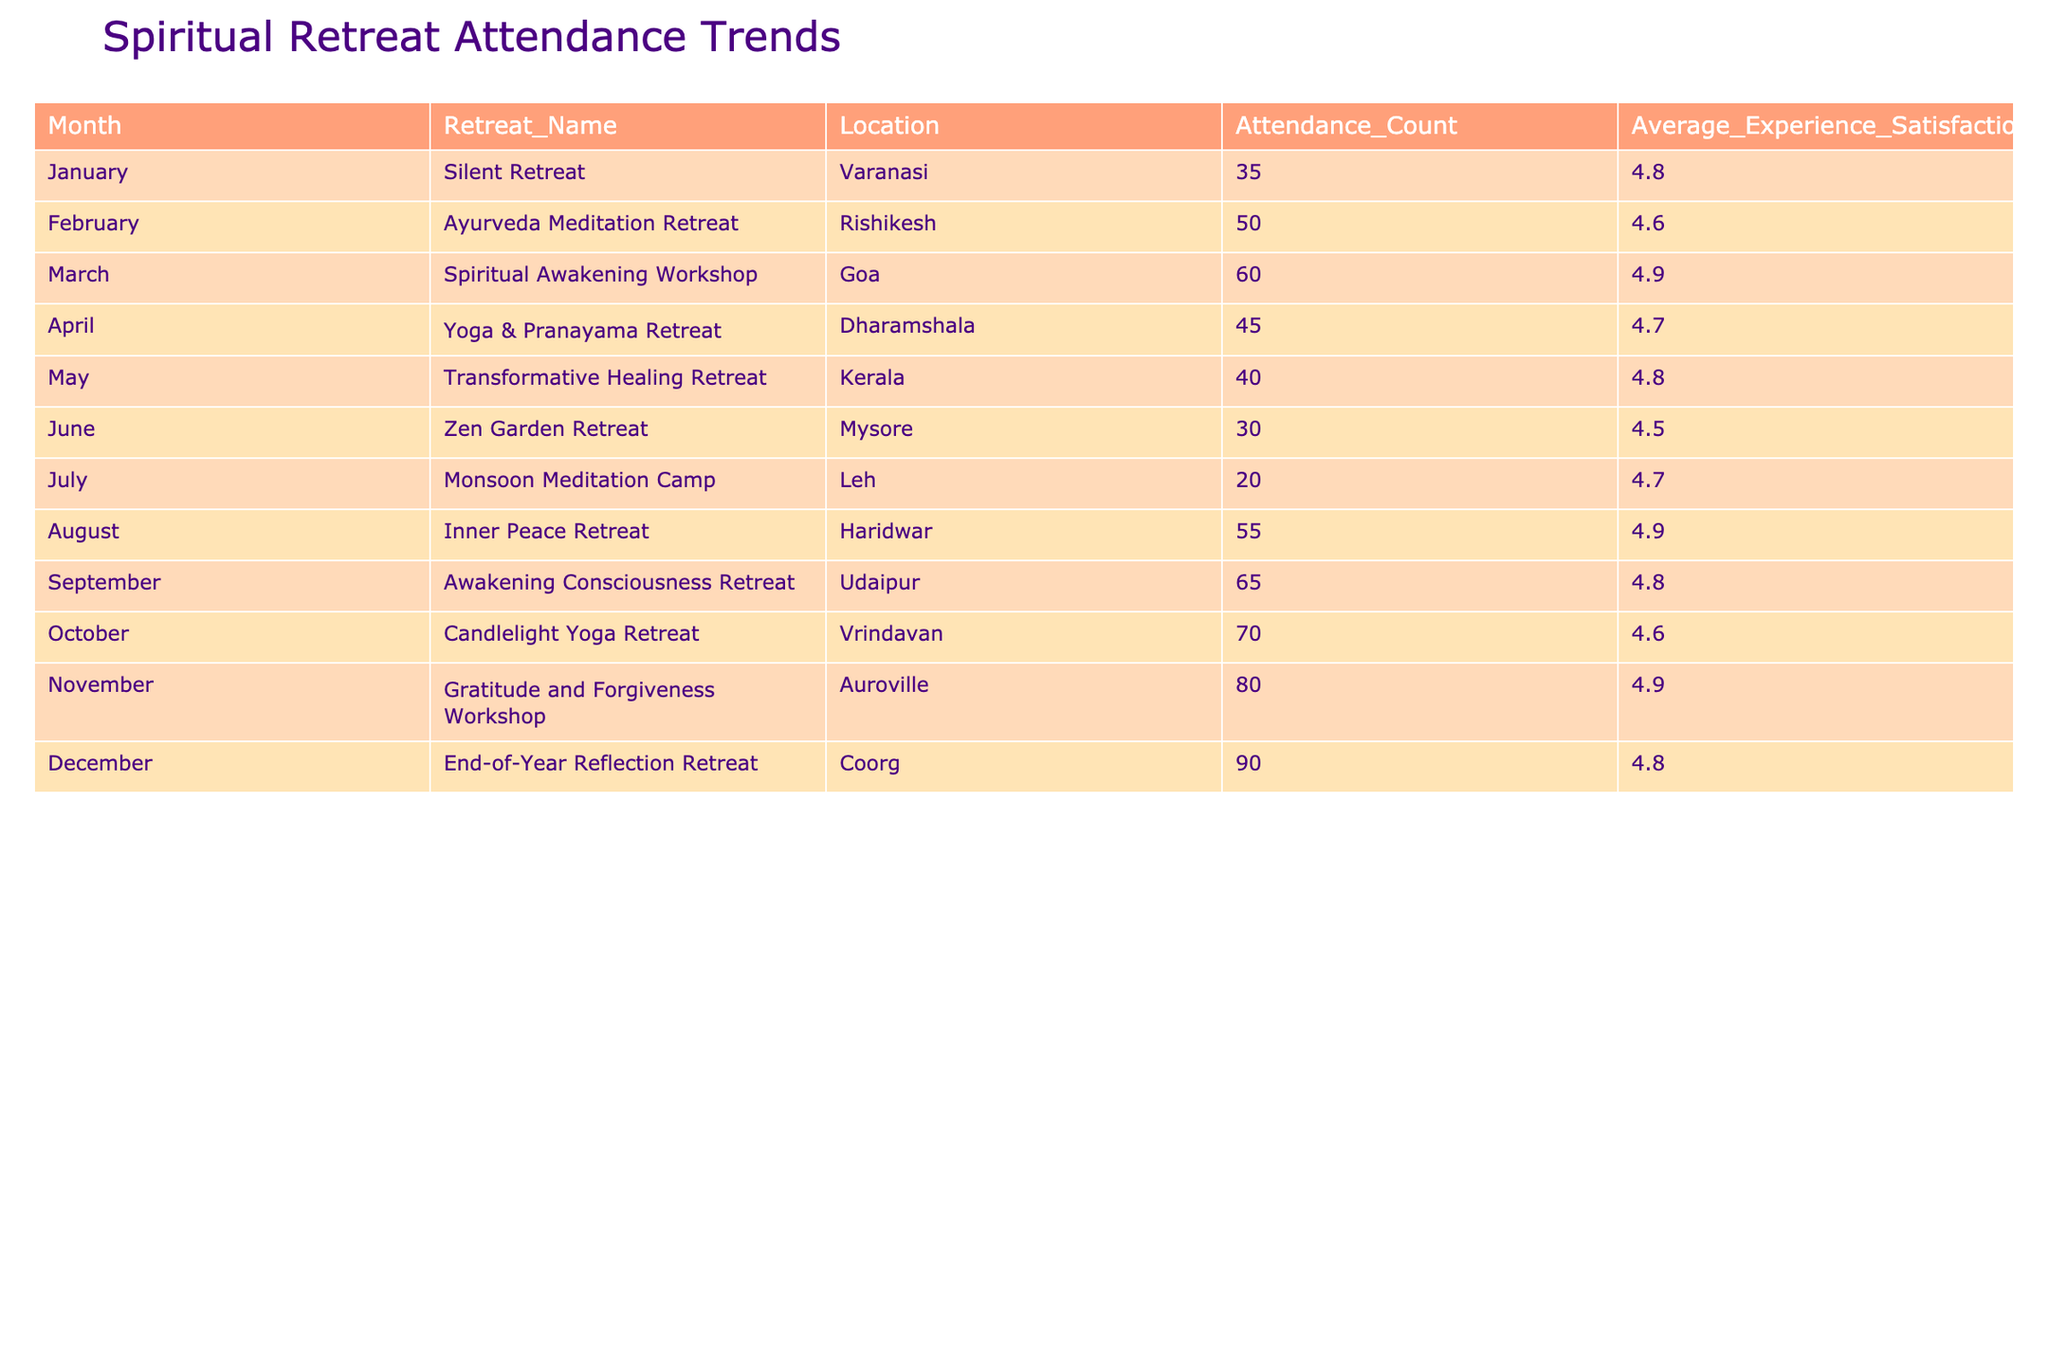What is the attendance count for the Candlelight Yoga Retreat in October? According to the table, the attendance count for the Candlelight Yoga Retreat listed under October is 70.
Answer: 70 Which month had the highest attendance count, and what was that count? By examining the attendance counts for each month, it's clear that December had the highest attendance count of 90 for the End-of-Year Reflection Retreat.
Answer: December, 90 What is the average experience satisfaction rating for the Transformative Healing Retreat in May? The table shows that the average experience satisfaction for the Transformative Healing Retreat in May is 4.8.
Answer: 4.8 Calculate the total attendance count for retreats held in the first half of the year (January to June). Summing the attendance counts from January to June gives: 35 (January) + 50 (February) + 60 (March) + 45 (April) + 40 (May) + 30 (June) = 260. Thus, the total attendance for the first half of the year is 260.
Answer: 260 Is the average experience satisfaction rating higher for the Inner Peace Retreat in August compared to the Monsoon Meditation Camp in July? The average satisfaction rating for the Inner Peace Retreat in August is 4.9, while for the Monsoon Meditation Camp in July, it is 4.7. Therefore, the Inner Peace Retreat has a higher average satisfaction rating.
Answer: Yes What is the difference in attendance counts between the Gratitude and Forgiveness Workshop in November and the Zen Garden Retreat in June? The attendance count for the Gratitude and Forgiveness Workshop in November is 80, and for the Zen Garden Retreat in June, it is 30. The difference is 80 - 30 = 50.
Answer: 50 Which retreat had the lowest average experience satisfaction rating? By reviewing the average experience satisfaction ratings, the Zen Garden Retreat in June has the lowest rating of 4.5.
Answer: Zen Garden Retreat, 4.5 If we consider only the retreats in the second half of the year (July to December), calculate the average attendance count. The attendance counts from July to December are: 20 (July) + 55 (August) + 65 (September) + 70 (October) + 80 (November) + 90 (December) = 400. There are 6 months, so the average attendance is 400/6 = approximately 66.67.
Answer: 66.67 